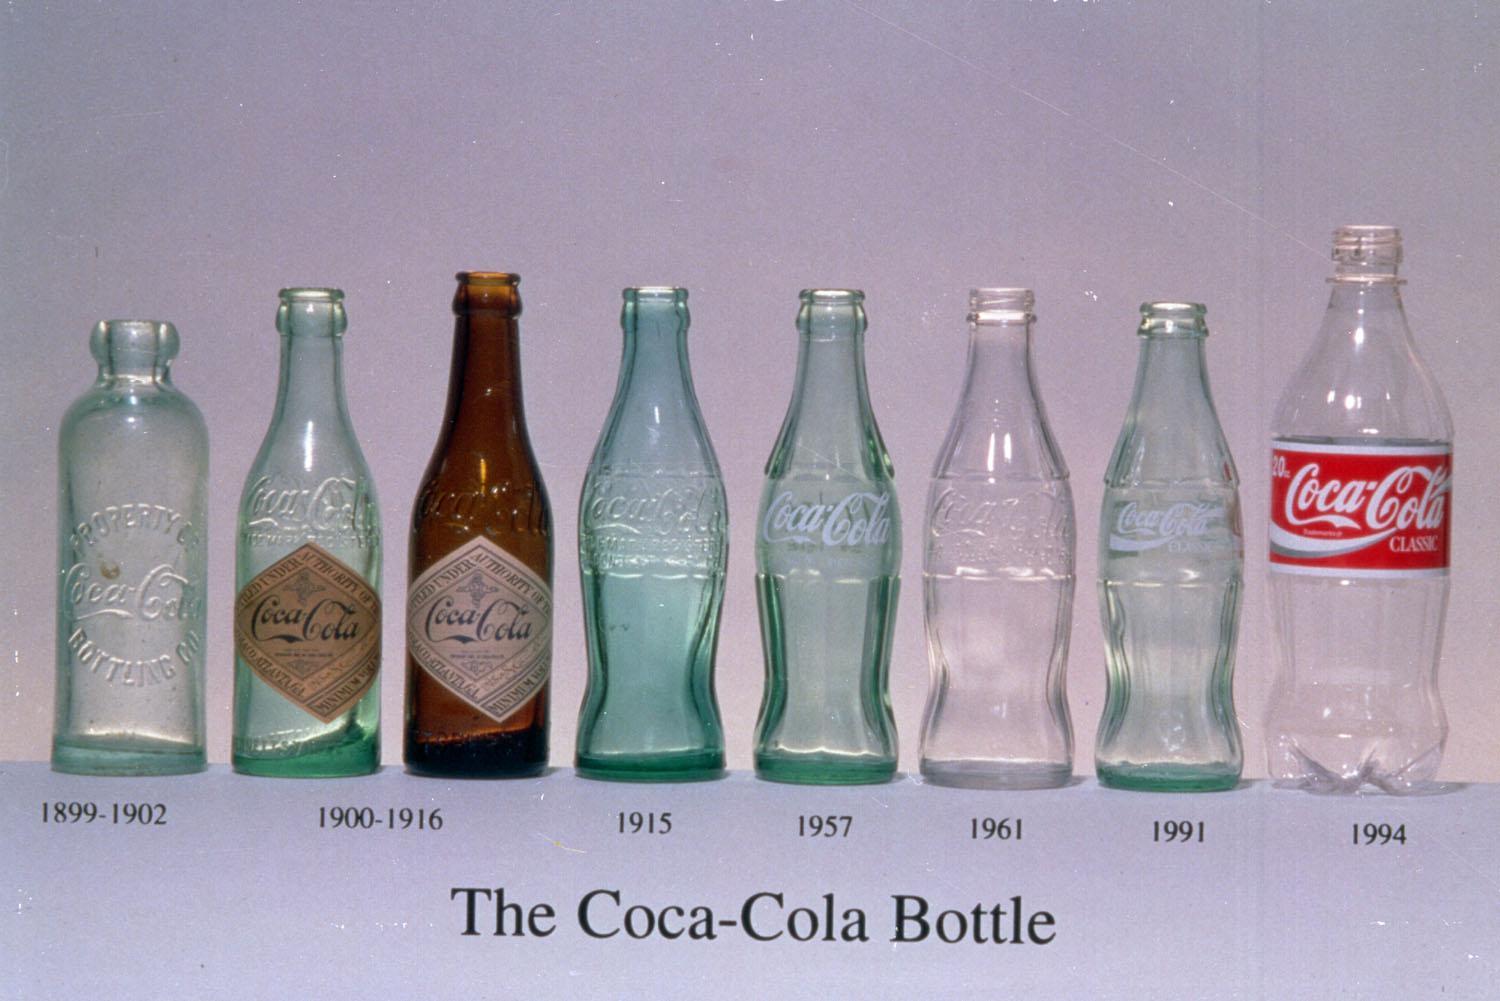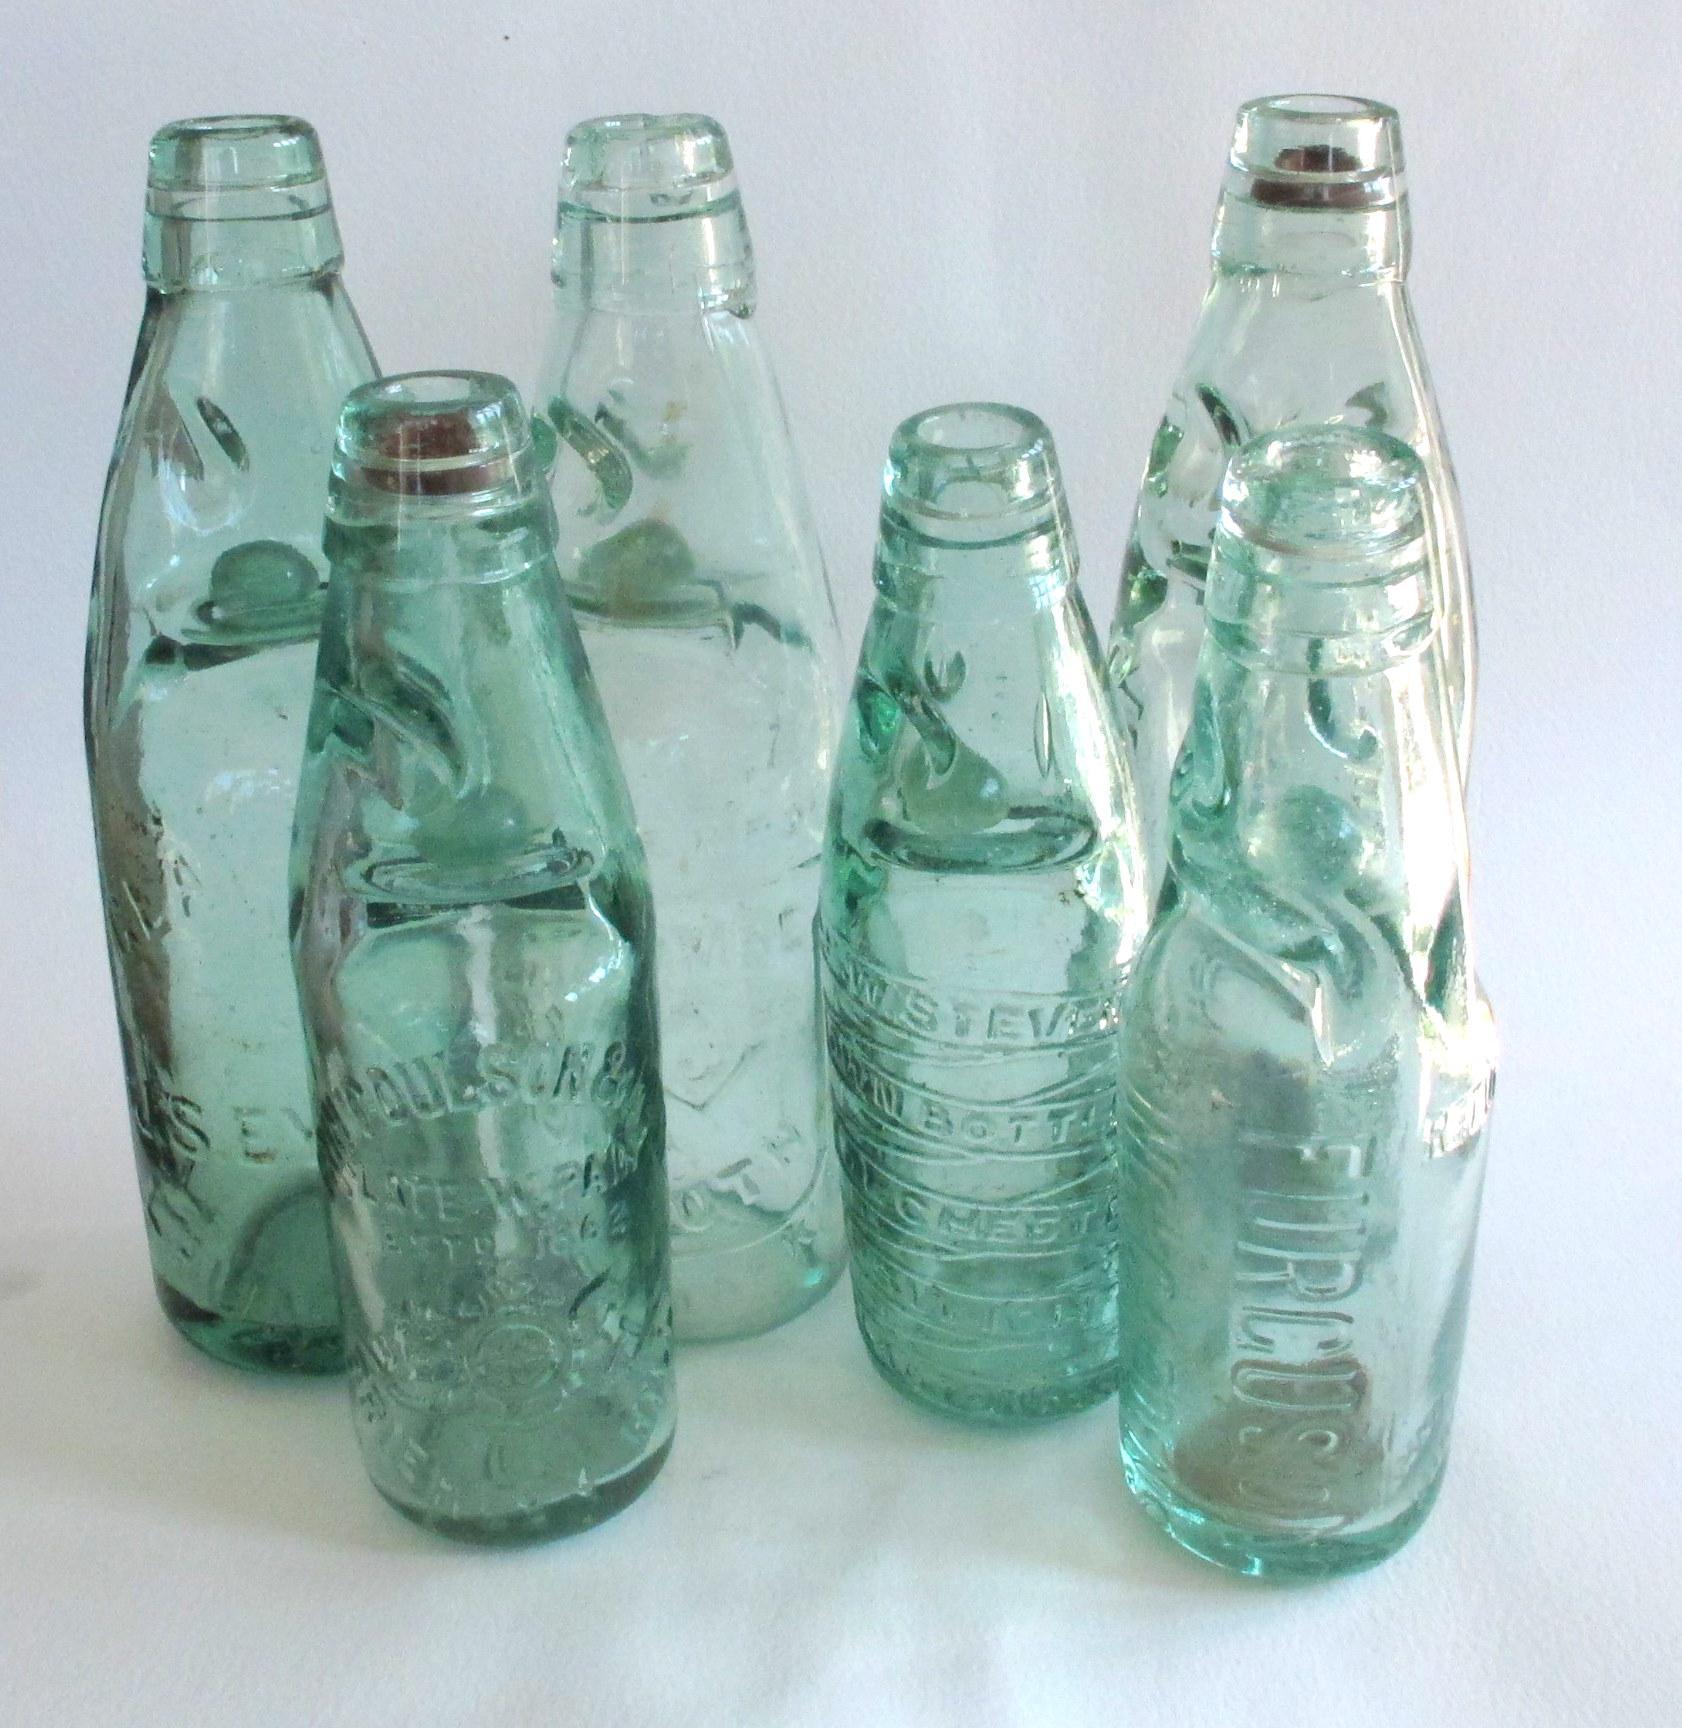The first image is the image on the left, the second image is the image on the right. Evaluate the accuracy of this statement regarding the images: "One of the bottles is filled with red liquid.". Is it true? Answer yes or no. No. The first image is the image on the left, the second image is the image on the right. For the images displayed, is the sentence "There are no more than three bottles in the right image." factually correct? Answer yes or no. No. 